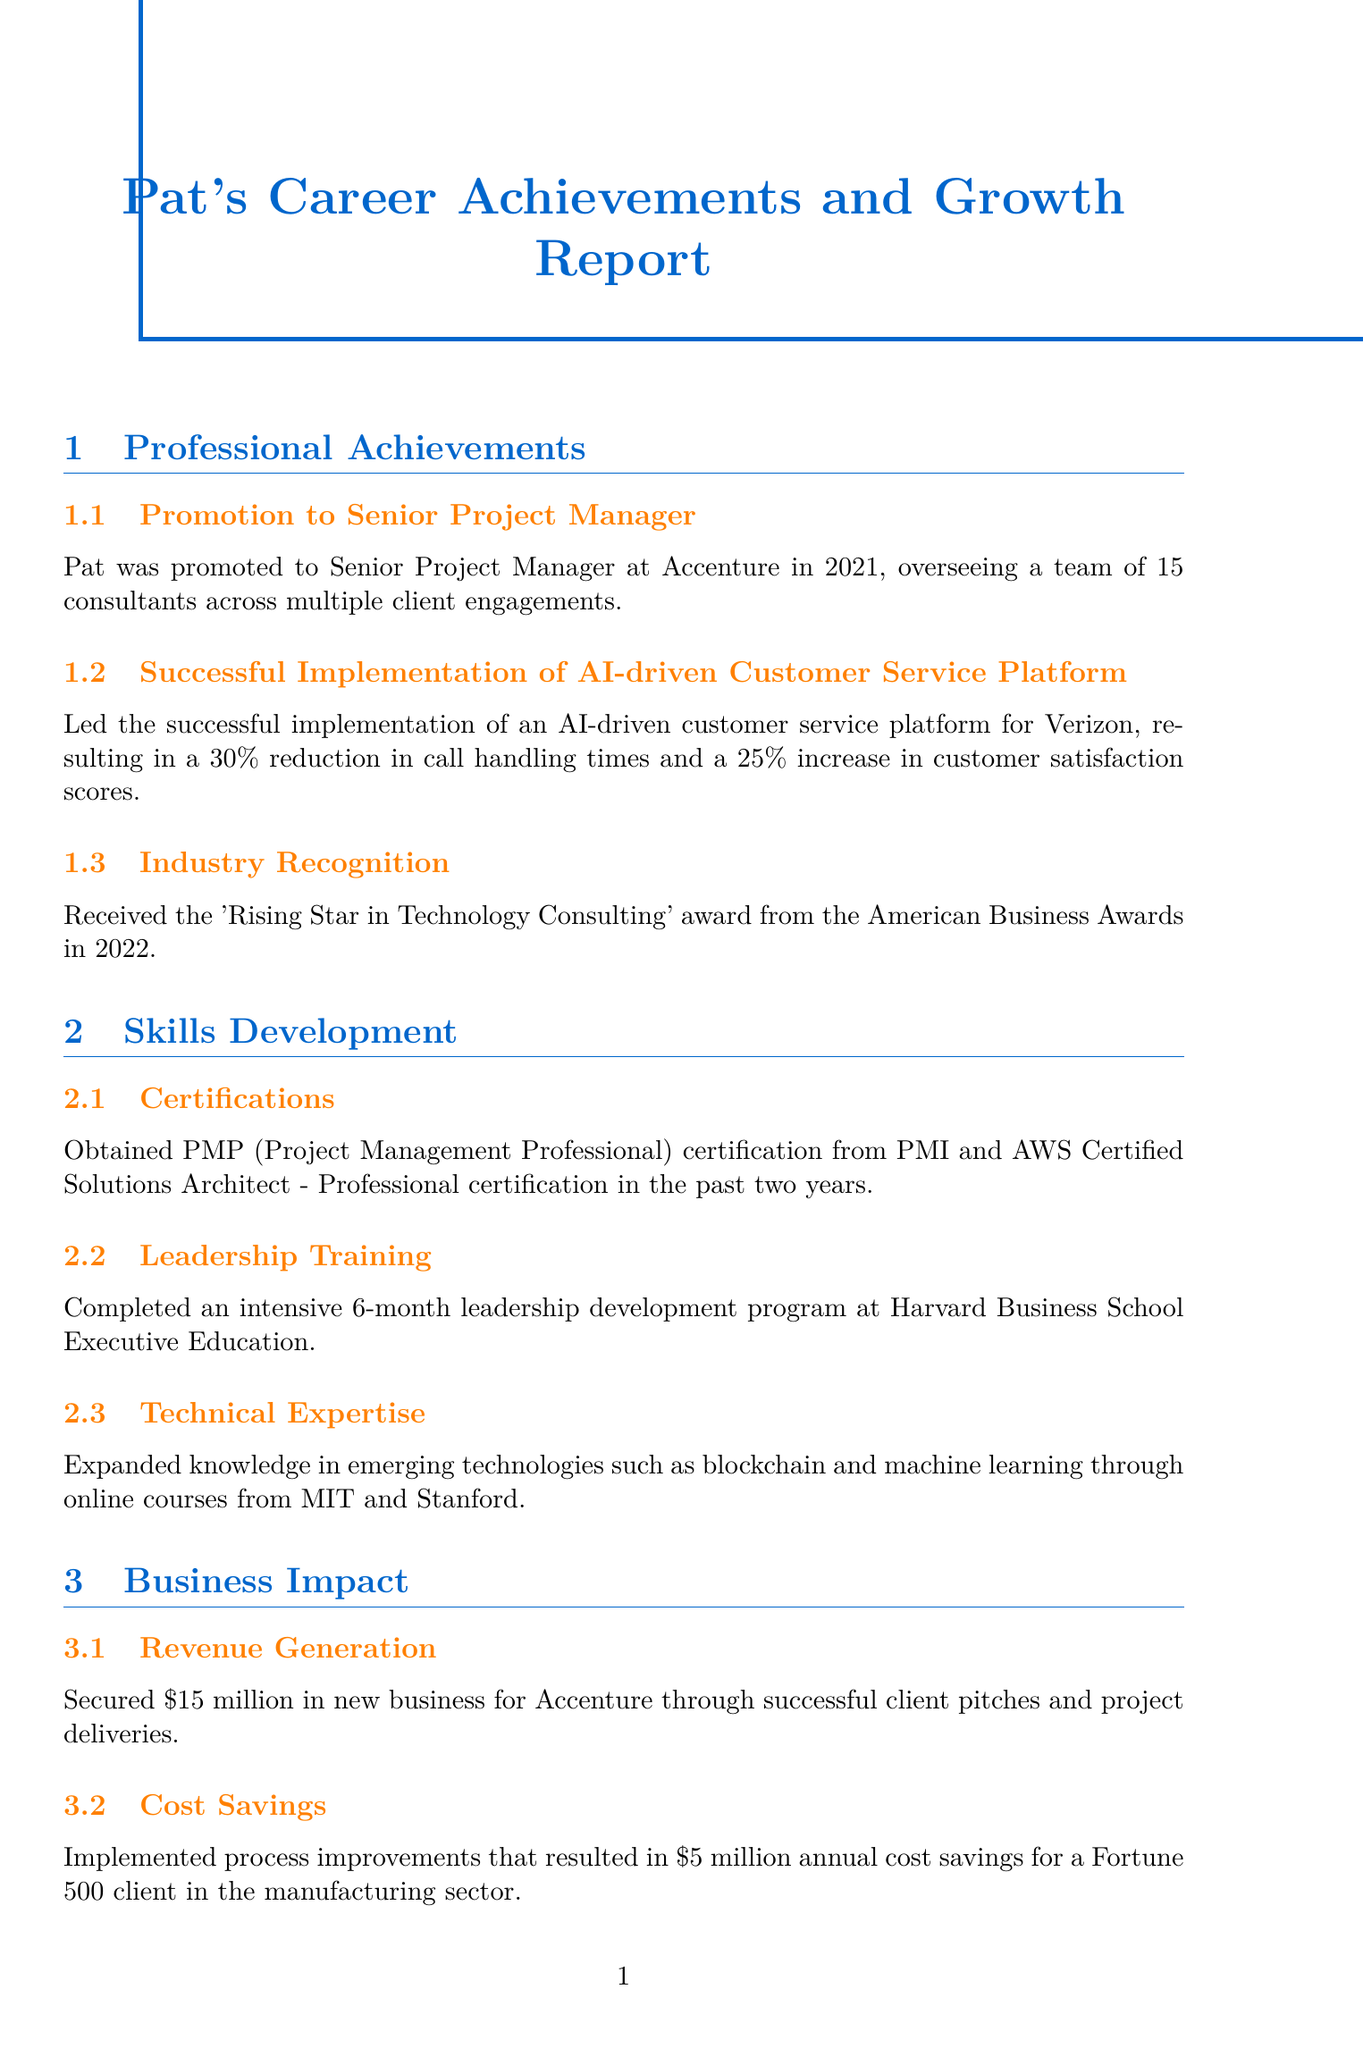What year was Pat promoted to Senior Project Manager? The document states that Pat was promoted to Senior Project Manager at Accenture in 2021.
Answer: 2021 What was the percentage increase in customer satisfaction scores for Verizon's platform? The document mentions a 25% increase in customer satisfaction scores resulting from the implementation of the AI-driven customer service platform for Verizon.
Answer: 25% How many key statistics are listed in the report? The report contains a section titled “Key Statistics” that lists six specific statistics.
Answer: 6 What award did Pat receive in 2022? The report details that Pat received the 'Rising Star in Technology Consulting' award from the American Business Awards in 2022.
Answer: Rising Star in Technology Consulting What was the revenue generated for Accenture through successful client pitches? According to the document, Pat secured $15 million in new business for Accenture through successful client pitches and project deliveries.
Answer: $15 million How many projects has Pat completed? The document states Pat has completed 23 projects during his time at Accenture.
Answer: 23 What type of program did Pat initiate for junior consultants? The report says that Pat initiated and led a mentorship program for junior consultants.
Answer: Mentorship program What is the focus of the new practice Pat is spearheading within Accenture? The report mentions that Pat is spearheading a new practice focused on sustainable technology solutions for clients in the energy sector.
Answer: Sustainable technology solutions How much annual cost savings did Pat deliver for a Fortune 500 client? The document specifies that Pat implemented process improvements that resulted in $5 million annual cost savings for a Fortune 500 client.
Answer: $5 million 